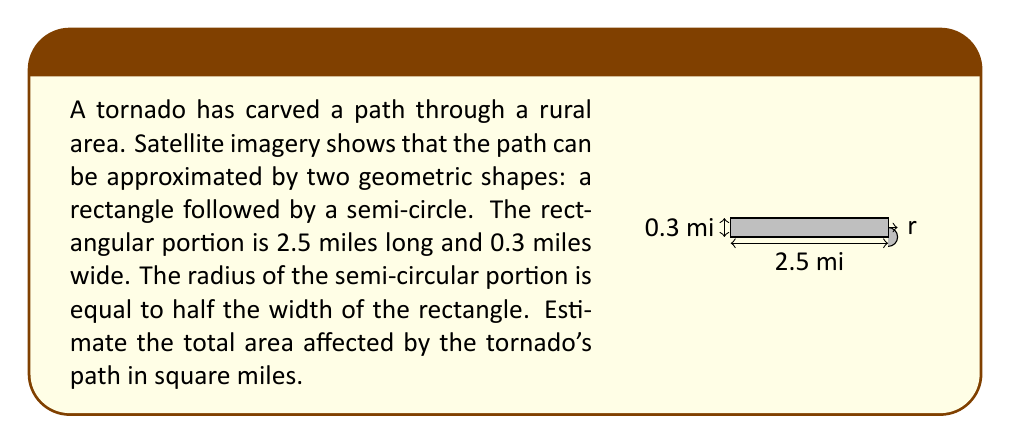Could you help me with this problem? Let's break this problem down step-by-step:

1) First, let's calculate the area of the rectangle:
   $$ A_{rectangle} = length \times width = 2.5 \times 0.3 = 0.75 \text{ sq miles} $$

2) Now, for the semi-circle:
   - The radius is half the width of the rectangle
   - $r = 0.3 \div 2 = 0.15 \text{ miles}$

3) The area of a full circle is $\pi r^2$, so the area of a semi-circle is half of that:
   $$ A_{semi-circle} = \frac{1}{2} \pi r^2 = \frac{1}{2} \pi (0.15)^2 $$

4) Let's calculate this:
   $$ A_{semi-circle} = \frac{1}{2} \pi (0.15)^2 \approx 0.0353 \text{ sq miles} $$

5) Now, we sum the areas of both shapes:
   $$ A_{total} = A_{rectangle} + A_{semi-circle} = 0.75 + 0.0353 = 0.7853 \text{ sq miles} $$

6) Rounding to two decimal places for a reasonable estimate:
   $$ A_{total} \approx 0.79 \text{ sq miles} $$
Answer: 0.79 sq miles 